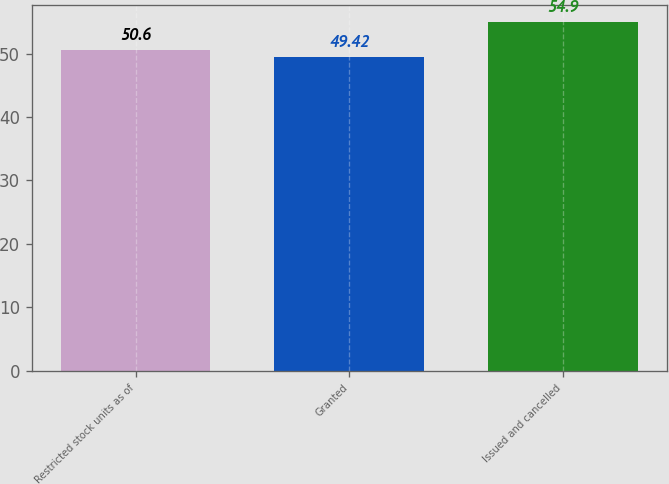Convert chart. <chart><loc_0><loc_0><loc_500><loc_500><bar_chart><fcel>Restricted stock units as of<fcel>Granted<fcel>Issued and cancelled<nl><fcel>50.6<fcel>49.42<fcel>54.9<nl></chart> 